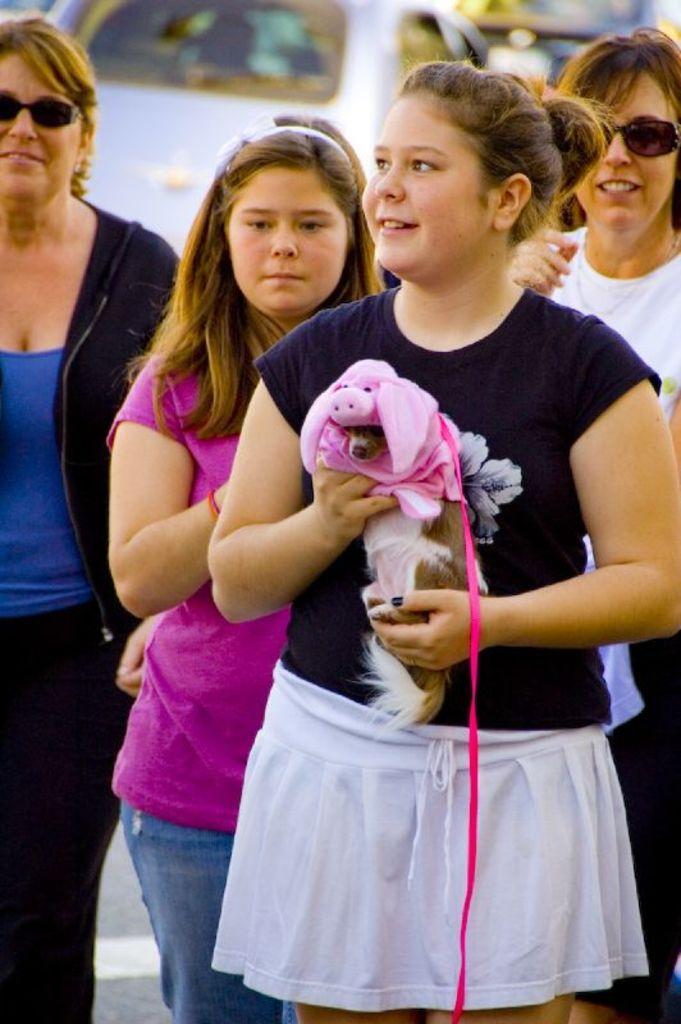Please provide a concise description of this image. In the given image i can see four girls standing and the girl who is standing in front and holding a puppy and behind this four women's , I can see a car inside the car , There is a person , Who is driving. 